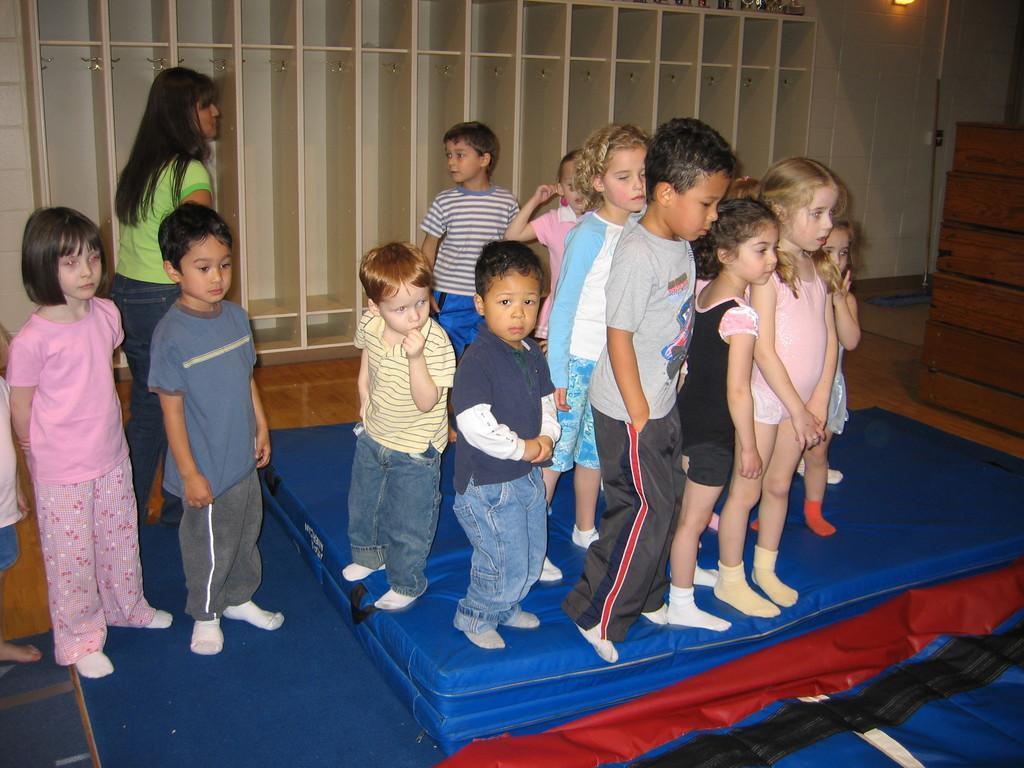Describe this image in one or two sentences. In the picture we can see a sponge stage, which is blue in color with some children standing on it and beside it also we can see two children are standing, and behind them, we can see a woman and in the background, we can see a wall with some rocks and beside it we can see a wall with a light to it and besides we can see some wooden planks are placed on the floor. 